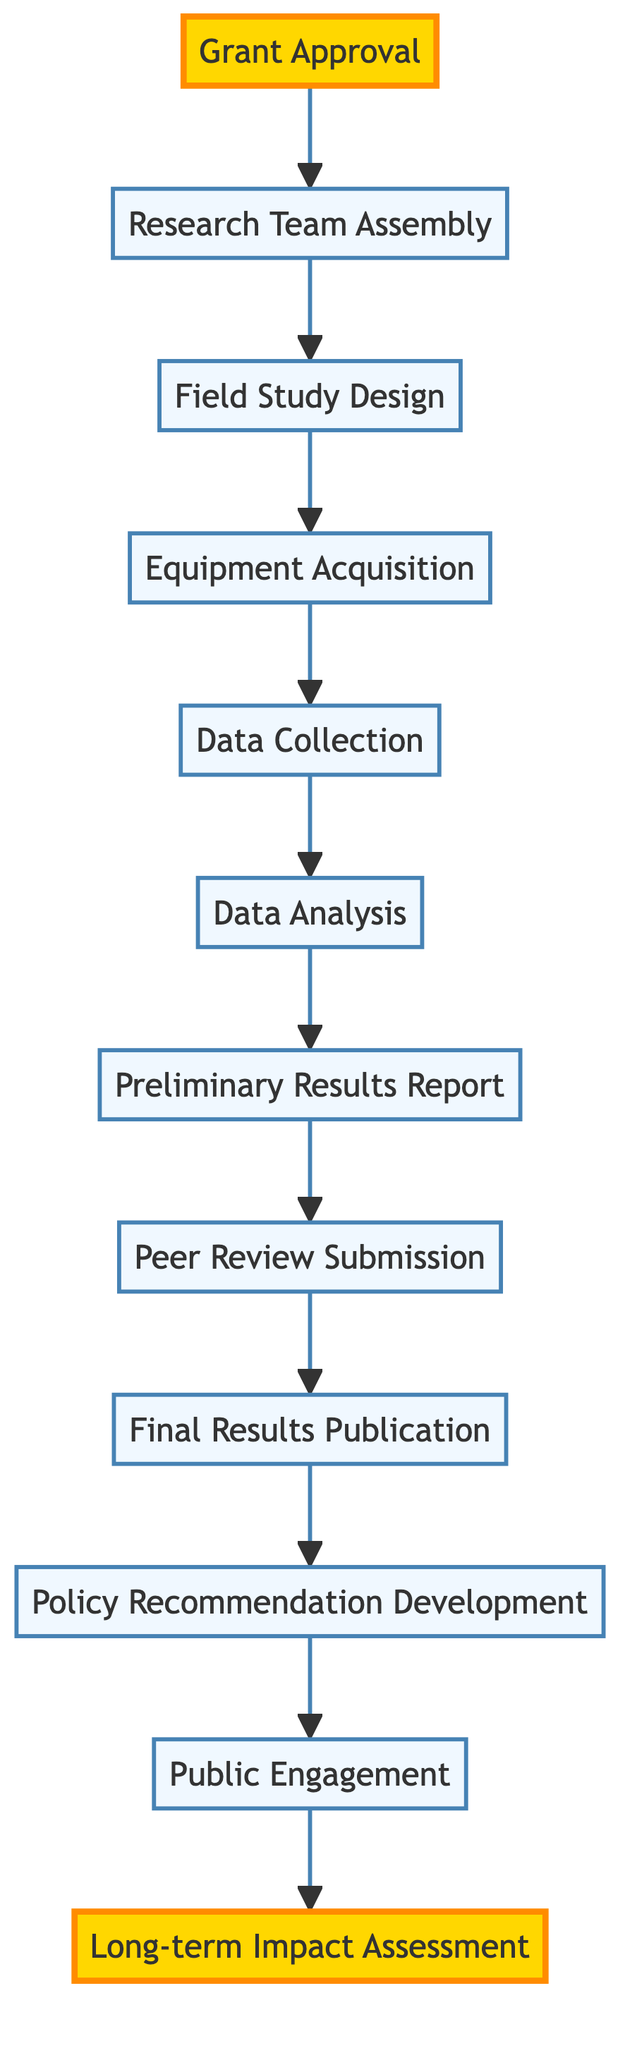What is the first step in the project lifecycle? The diagram indicates that the first step is "Grant Approval," which is the starting node of the directed graph.
Answer: Grant Approval How many nodes are present in the diagram? By counting the entries in the nodes list, there are 11 nodes in total representing different steps in the project lifecycle.
Answer: 11 Which step follows "Preliminary Results Report"? The directed edge from "Preliminary Results Report" leads to "Peer Review Submission," indicating that this is the next step in the process.
Answer: Peer Review Submission What is the last activity in the project lifecycle? The diagram shows "Long-term Impact Assessment" as the final step, where the project's overall impact is evaluated.
Answer: Long-term Impact Assessment What is the relationship between "Equipment Acquisition" and "Data Collection"? The directed edge from "Equipment Acquisition" points to "Data Collection," showing that the equipment must be acquired before data can be collected.
Answer: Equipment Acquisition leads to Data Collection What is the total number of directed edges in the diagram? By counting the connections represented in the edges list, there are 10 directed edges that connect the nodes sequentially from grant approval to long-term impact assessment.
Answer: 10 What comes before "Policy Recommendation Development"? Following the arrows in the diagram, "Final Results Publication" directly precedes "Policy Recommendation Development."
Answer: Final Results Publication Which step connects to "Public Engagement"? The edge directed from "Policy Recommendation Development" leads to "Public Engagement," indicating this connection within the flow of the project steps.
Answer: Policy Recommendation Development 